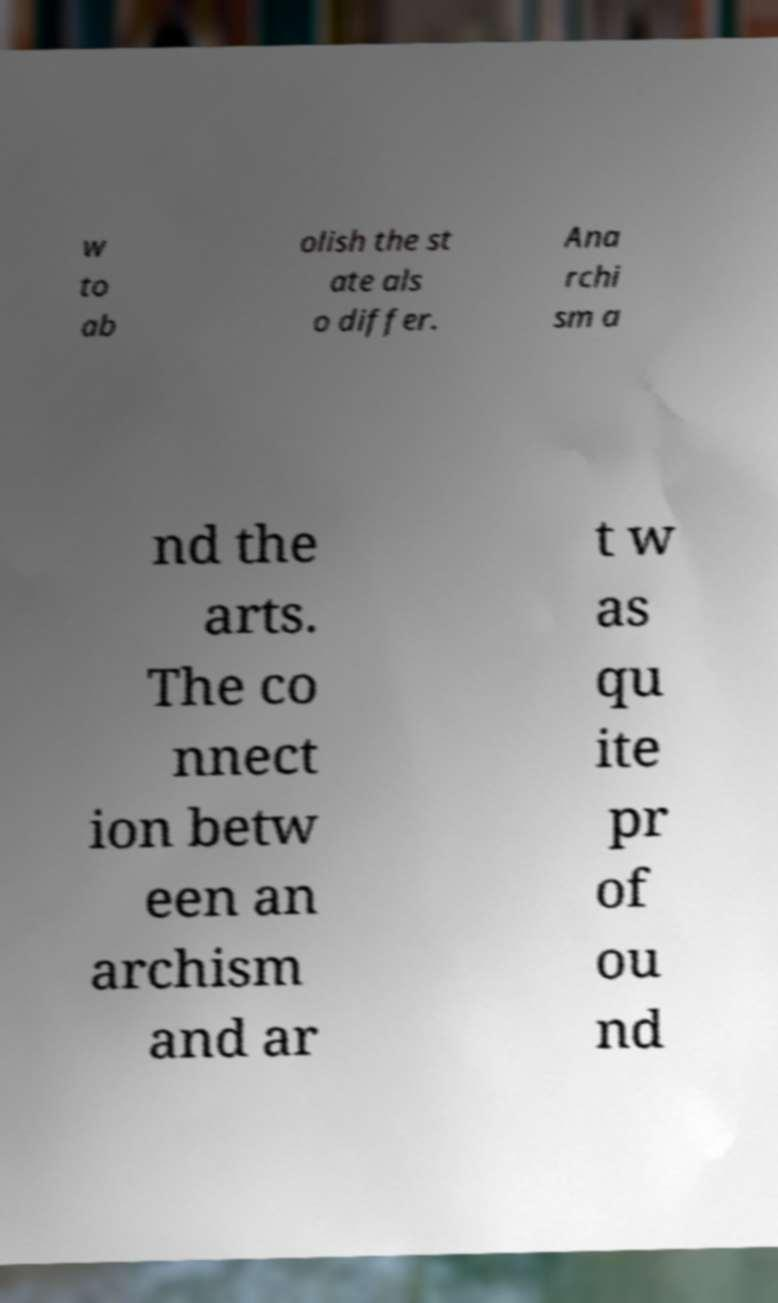What messages or text are displayed in this image? I need them in a readable, typed format. w to ab olish the st ate als o differ. Ana rchi sm a nd the arts. The co nnect ion betw een an archism and ar t w as qu ite pr of ou nd 